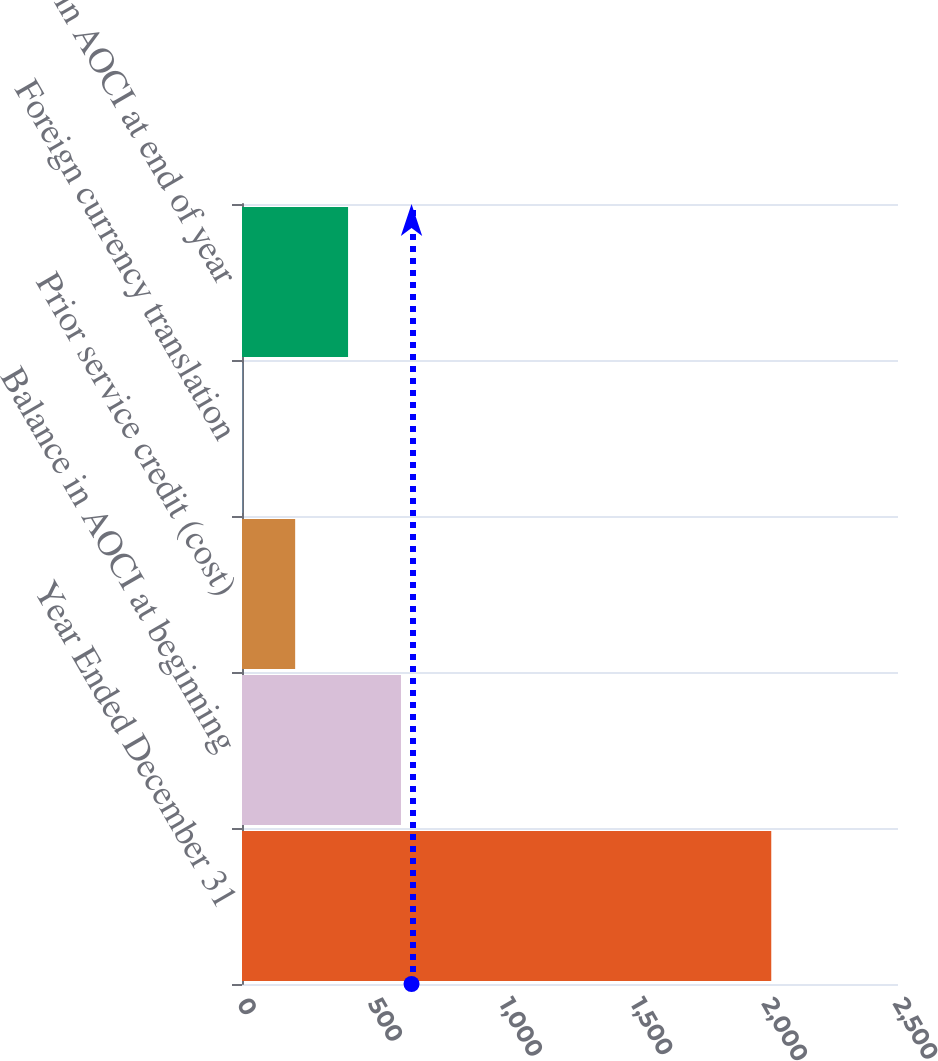Convert chart to OTSL. <chart><loc_0><loc_0><loc_500><loc_500><bar_chart><fcel>Year Ended December 31<fcel>Balance in AOCI at beginning<fcel>Prior service credit (cost)<fcel>Foreign currency translation<fcel>Balance in AOCI at end of year<nl><fcel>2017<fcel>605.8<fcel>202.6<fcel>1<fcel>404.2<nl></chart> 